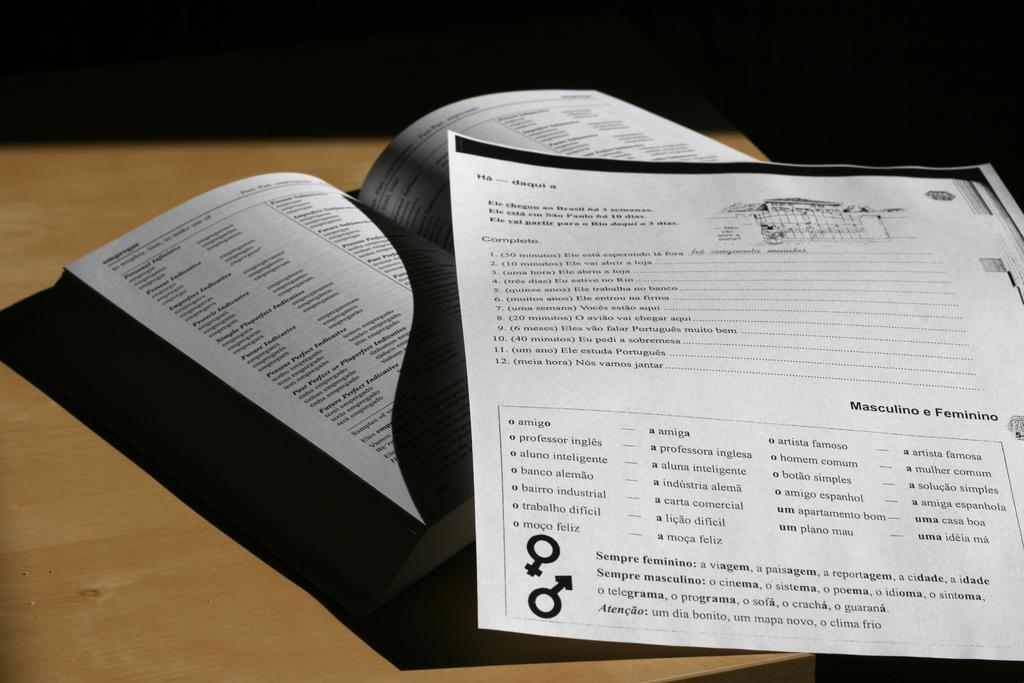<image>
Present a compact description of the photo's key features. A student's language worksheet that reads things like Sempre feminino at the bottom. 